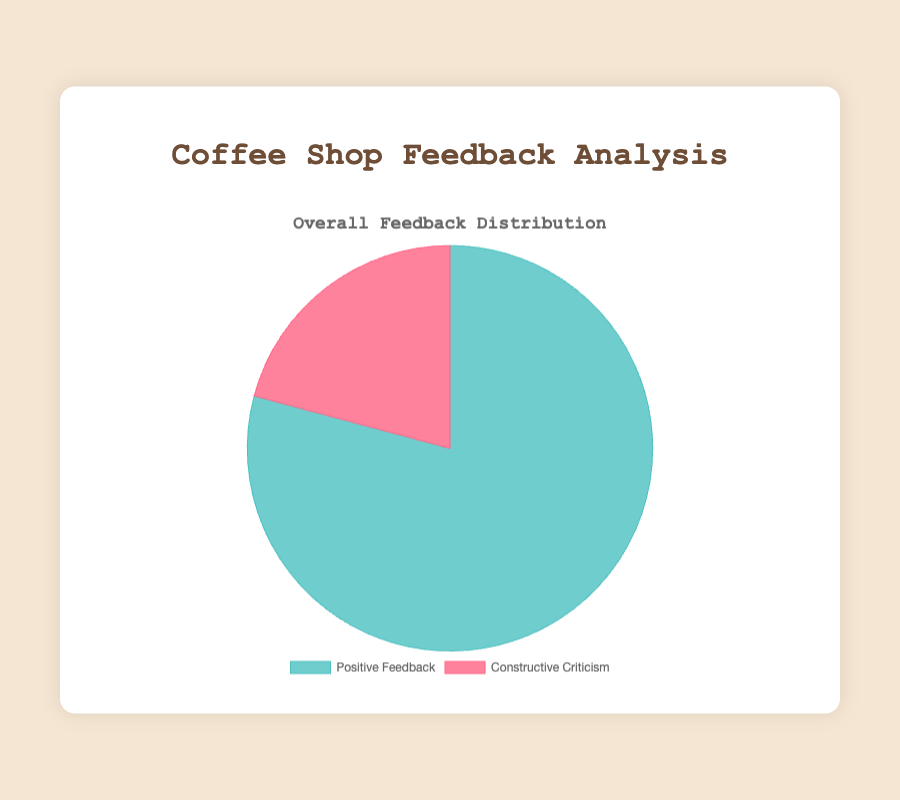What percentage of the feedback is positive? Add up the total positive feedback (150 + 180 + 160 + 140 + 130 = 760). Add up the total feedback (760 positive + 200 constructive = 960). Calculate the percentage (760 / 960 * 100).
Answer: 79.2% What percentage of the feedback is constructive criticism? Add up the total constructive criticism (30 + 20 + 40 + 50 + 60 = 200). Add up the total feedback (760 positive + 200 constructive = 960). Calculate the percentage (200 / 960 * 100).
Answer: 20.8% Is the positive feedback greater than the constructive criticism for all the categories? Yes, check each category. For coffee quality: 150 > 30, for customer service: 180 > 20, for ambiance: 160 > 40, for menu variety: 140 > 50, for pricing: 130 > 60.
Answer: Yes Which feedback category received the most constructive criticism? Compare constructive criticism values: 30 for coffee quality, 20 for customer service, 40 for ambiance, 50 for menu variety, 60 for pricing. Pricing has the highest value.
Answer: Pricing Which feedback category received the most positive feedback? Compare positive feedback values: 150 for coffee quality, 180 for customer service, 160 for ambiance, 140 for menu variety, 130 for pricing. Customer service has the highest value.
Answer: Customer Service What is the ratio of positive feedback to constructive criticism for ambiance? Positive feedback for ambiance is 160 and constructive criticism is 40. The ratio is 160:40, which simplifies to 4:1.
Answer: 4:1 What is the average amount of constructive criticism received across all categories? Add up the total constructive criticism (200) and divide by the number of categories (5). 200 / 5 = 40.
Answer: 40 How much more positive feedback did customer service receive compared to pricing? Positive feedback for customer service is 180 and for pricing is 130. Subtract the values (180 - 130).
Answer: 50 If 10 more positive feedback comments were added to coffee quality, what would be the new percentage of total positive feedback? New positive feedback for coffee quality would be 150 + 10 = 160. New total positive feedback would be 760 + 10 = 770. Calculate the new percentage (770 / 960 * 100).
Answer: 80.2% Which feedback category has the smallest difference between positive feedback and constructive criticism? Calculate the differences: coffee quality (150 - 30 = 120), customer service (180 - 20 = 160), ambiance (160 - 40 = 120), menu variety (140 - 50 = 90), pricing (130 - 60 = 70). Pricing has the smallest difference.
Answer: Pricing 